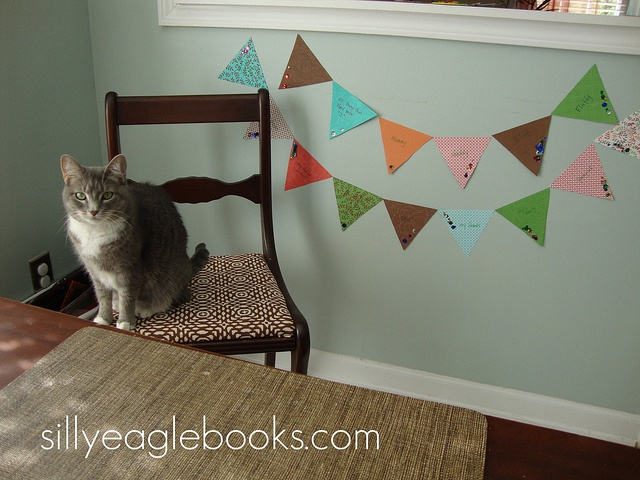Describe the objects in this image and their specific colors. I can see dining table in gray and olive tones, chair in gray, black, and darkgray tones, and cat in gray, black, and darkgray tones in this image. 